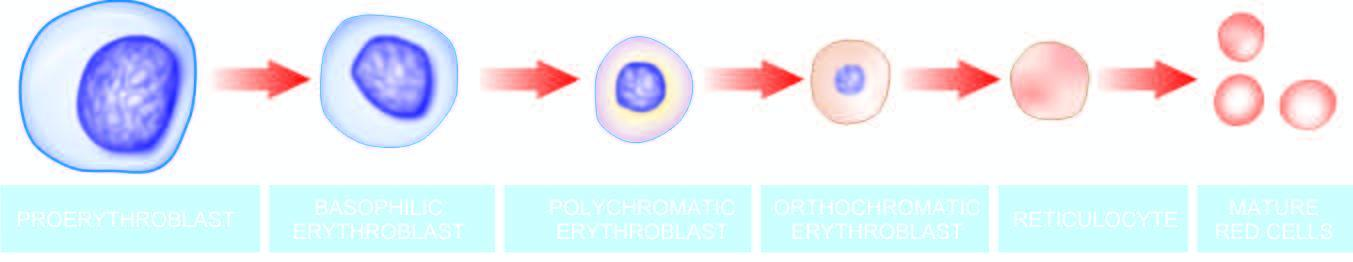what is there of the nuclear chromatin which is eventually extruded from the cell at the late erythroblast stage?
Answer the question using a single word or phrase. Progressive condensation of the nuclear chromatin 